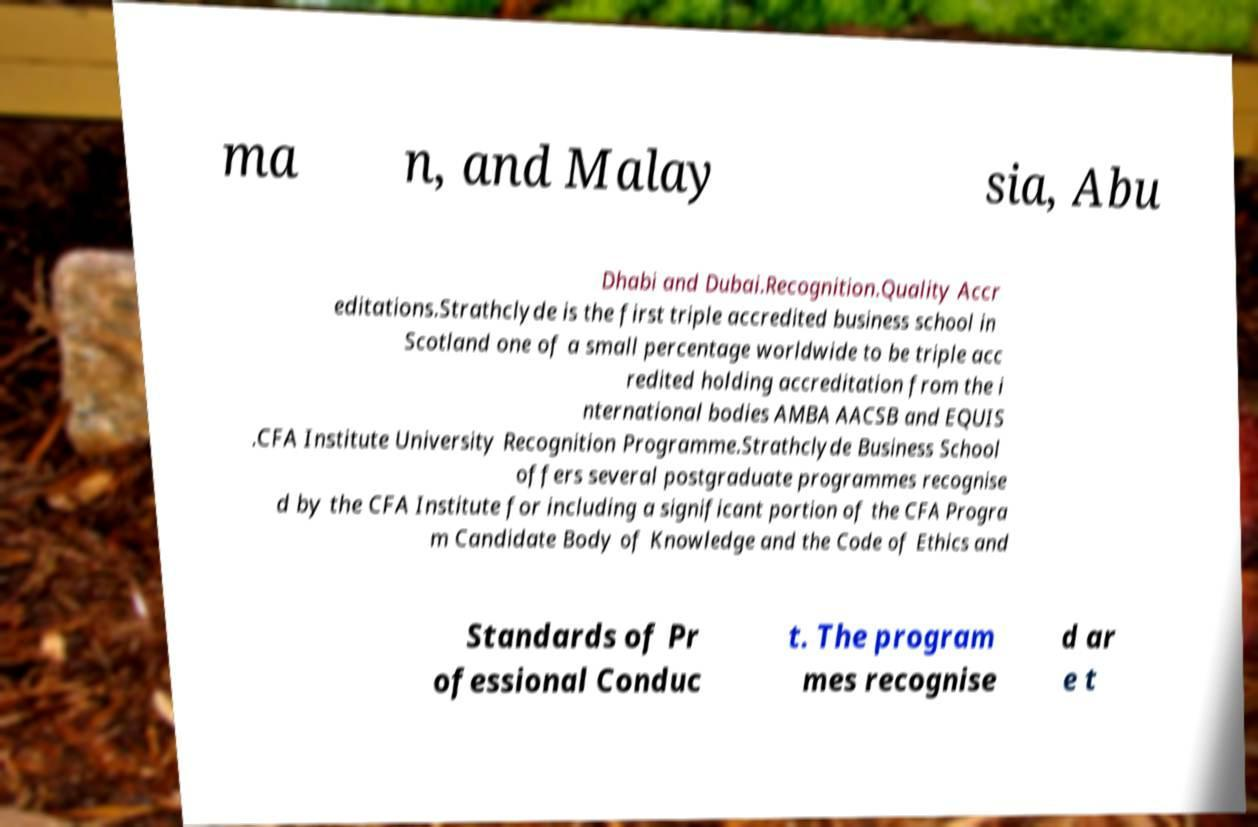Please identify and transcribe the text found in this image. ma n, and Malay sia, Abu Dhabi and Dubai.Recognition.Quality Accr editations.Strathclyde is the first triple accredited business school in Scotland one of a small percentage worldwide to be triple acc redited holding accreditation from the i nternational bodies AMBA AACSB and EQUIS .CFA Institute University Recognition Programme.Strathclyde Business School offers several postgraduate programmes recognise d by the CFA Institute for including a significant portion of the CFA Progra m Candidate Body of Knowledge and the Code of Ethics and Standards of Pr ofessional Conduc t. The program mes recognise d ar e t 